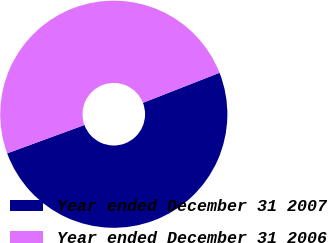Convert chart to OTSL. <chart><loc_0><loc_0><loc_500><loc_500><pie_chart><fcel>Year ended December 31 2007<fcel>Year ended December 31 2006<nl><fcel>50.35%<fcel>49.65%<nl></chart> 